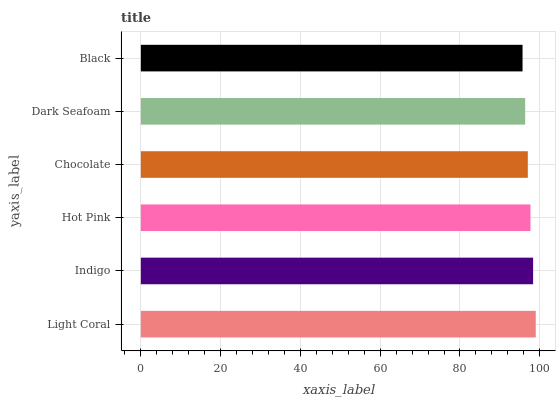Is Black the minimum?
Answer yes or no. Yes. Is Light Coral the maximum?
Answer yes or no. Yes. Is Indigo the minimum?
Answer yes or no. No. Is Indigo the maximum?
Answer yes or no. No. Is Light Coral greater than Indigo?
Answer yes or no. Yes. Is Indigo less than Light Coral?
Answer yes or no. Yes. Is Indigo greater than Light Coral?
Answer yes or no. No. Is Light Coral less than Indigo?
Answer yes or no. No. Is Hot Pink the high median?
Answer yes or no. Yes. Is Chocolate the low median?
Answer yes or no. Yes. Is Black the high median?
Answer yes or no. No. Is Indigo the low median?
Answer yes or no. No. 